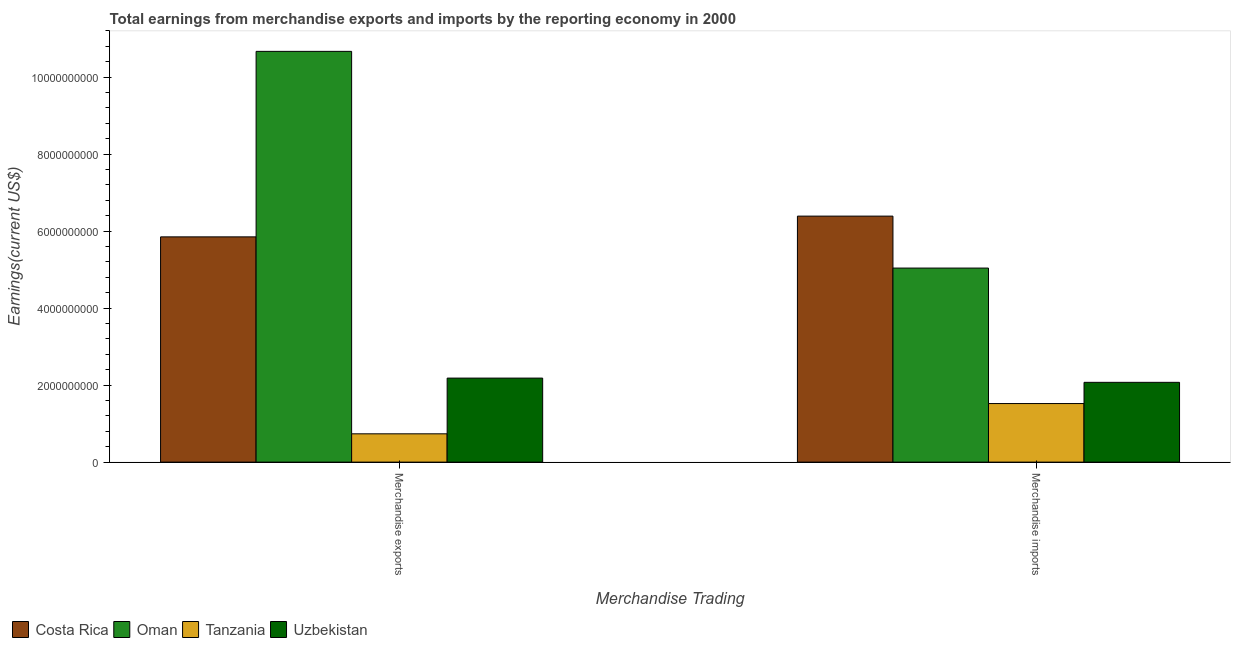How many different coloured bars are there?
Offer a terse response. 4. How many groups of bars are there?
Offer a terse response. 2. Are the number of bars on each tick of the X-axis equal?
Keep it short and to the point. Yes. How many bars are there on the 1st tick from the right?
Your answer should be compact. 4. What is the label of the 2nd group of bars from the left?
Give a very brief answer. Merchandise imports. What is the earnings from merchandise exports in Uzbekistan?
Make the answer very short. 2.18e+09. Across all countries, what is the maximum earnings from merchandise exports?
Your response must be concise. 1.07e+1. Across all countries, what is the minimum earnings from merchandise imports?
Offer a terse response. 1.52e+09. In which country was the earnings from merchandise exports maximum?
Keep it short and to the point. Oman. In which country was the earnings from merchandise exports minimum?
Offer a terse response. Tanzania. What is the total earnings from merchandise exports in the graph?
Keep it short and to the point. 1.94e+1. What is the difference between the earnings from merchandise exports in Uzbekistan and that in Oman?
Make the answer very short. -8.48e+09. What is the difference between the earnings from merchandise imports in Oman and the earnings from merchandise exports in Uzbekistan?
Give a very brief answer. 2.86e+09. What is the average earnings from merchandise imports per country?
Give a very brief answer. 3.76e+09. What is the difference between the earnings from merchandise exports and earnings from merchandise imports in Costa Rica?
Your response must be concise. -5.39e+08. In how many countries, is the earnings from merchandise exports greater than 400000000 US$?
Offer a terse response. 4. What is the ratio of the earnings from merchandise imports in Uzbekistan to that in Tanzania?
Offer a very short reply. 1.36. In how many countries, is the earnings from merchandise exports greater than the average earnings from merchandise exports taken over all countries?
Offer a terse response. 2. What does the 2nd bar from the left in Merchandise exports represents?
Ensure brevity in your answer.  Oman. What does the 1st bar from the right in Merchandise imports represents?
Offer a terse response. Uzbekistan. How many countries are there in the graph?
Give a very brief answer. 4. Does the graph contain any zero values?
Offer a very short reply. No. Where does the legend appear in the graph?
Ensure brevity in your answer.  Bottom left. How many legend labels are there?
Provide a succinct answer. 4. How are the legend labels stacked?
Make the answer very short. Horizontal. What is the title of the graph?
Provide a short and direct response. Total earnings from merchandise exports and imports by the reporting economy in 2000. Does "Hungary" appear as one of the legend labels in the graph?
Make the answer very short. No. What is the label or title of the X-axis?
Your answer should be very brief. Merchandise Trading. What is the label or title of the Y-axis?
Provide a succinct answer. Earnings(current US$). What is the Earnings(current US$) of Costa Rica in Merchandise exports?
Your response must be concise. 5.85e+09. What is the Earnings(current US$) in Oman in Merchandise exports?
Give a very brief answer. 1.07e+1. What is the Earnings(current US$) of Tanzania in Merchandise exports?
Make the answer very short. 7.35e+08. What is the Earnings(current US$) in Uzbekistan in Merchandise exports?
Ensure brevity in your answer.  2.18e+09. What is the Earnings(current US$) of Costa Rica in Merchandise imports?
Offer a terse response. 6.39e+09. What is the Earnings(current US$) in Oman in Merchandise imports?
Your answer should be compact. 5.04e+09. What is the Earnings(current US$) in Tanzania in Merchandise imports?
Give a very brief answer. 1.52e+09. What is the Earnings(current US$) in Uzbekistan in Merchandise imports?
Your answer should be compact. 2.07e+09. Across all Merchandise Trading, what is the maximum Earnings(current US$) of Costa Rica?
Provide a succinct answer. 6.39e+09. Across all Merchandise Trading, what is the maximum Earnings(current US$) of Oman?
Keep it short and to the point. 1.07e+1. Across all Merchandise Trading, what is the maximum Earnings(current US$) of Tanzania?
Provide a succinct answer. 1.52e+09. Across all Merchandise Trading, what is the maximum Earnings(current US$) of Uzbekistan?
Offer a very short reply. 2.18e+09. Across all Merchandise Trading, what is the minimum Earnings(current US$) in Costa Rica?
Your answer should be very brief. 5.85e+09. Across all Merchandise Trading, what is the minimum Earnings(current US$) in Oman?
Your answer should be compact. 5.04e+09. Across all Merchandise Trading, what is the minimum Earnings(current US$) of Tanzania?
Your answer should be very brief. 7.35e+08. Across all Merchandise Trading, what is the minimum Earnings(current US$) of Uzbekistan?
Provide a succinct answer. 2.07e+09. What is the total Earnings(current US$) in Costa Rica in the graph?
Make the answer very short. 1.22e+1. What is the total Earnings(current US$) in Oman in the graph?
Offer a very short reply. 1.57e+1. What is the total Earnings(current US$) of Tanzania in the graph?
Ensure brevity in your answer.  2.26e+09. What is the total Earnings(current US$) in Uzbekistan in the graph?
Your response must be concise. 4.25e+09. What is the difference between the Earnings(current US$) of Costa Rica in Merchandise exports and that in Merchandise imports?
Offer a very short reply. -5.39e+08. What is the difference between the Earnings(current US$) in Oman in Merchandise exports and that in Merchandise imports?
Provide a short and direct response. 5.63e+09. What is the difference between the Earnings(current US$) of Tanzania in Merchandise exports and that in Merchandise imports?
Your response must be concise. -7.86e+08. What is the difference between the Earnings(current US$) in Uzbekistan in Merchandise exports and that in Merchandise imports?
Make the answer very short. 1.10e+08. What is the difference between the Earnings(current US$) in Costa Rica in Merchandise exports and the Earnings(current US$) in Oman in Merchandise imports?
Keep it short and to the point. 8.10e+08. What is the difference between the Earnings(current US$) in Costa Rica in Merchandise exports and the Earnings(current US$) in Tanzania in Merchandise imports?
Your answer should be compact. 4.33e+09. What is the difference between the Earnings(current US$) of Costa Rica in Merchandise exports and the Earnings(current US$) of Uzbekistan in Merchandise imports?
Provide a short and direct response. 3.78e+09. What is the difference between the Earnings(current US$) of Oman in Merchandise exports and the Earnings(current US$) of Tanzania in Merchandise imports?
Offer a terse response. 9.15e+09. What is the difference between the Earnings(current US$) of Oman in Merchandise exports and the Earnings(current US$) of Uzbekistan in Merchandise imports?
Provide a short and direct response. 8.59e+09. What is the difference between the Earnings(current US$) in Tanzania in Merchandise exports and the Earnings(current US$) in Uzbekistan in Merchandise imports?
Provide a short and direct response. -1.34e+09. What is the average Earnings(current US$) of Costa Rica per Merchandise Trading?
Your answer should be very brief. 6.12e+09. What is the average Earnings(current US$) of Oman per Merchandise Trading?
Your answer should be very brief. 7.85e+09. What is the average Earnings(current US$) in Tanzania per Merchandise Trading?
Provide a short and direct response. 1.13e+09. What is the average Earnings(current US$) in Uzbekistan per Merchandise Trading?
Offer a very short reply. 2.13e+09. What is the difference between the Earnings(current US$) in Costa Rica and Earnings(current US$) in Oman in Merchandise exports?
Give a very brief answer. -4.82e+09. What is the difference between the Earnings(current US$) of Costa Rica and Earnings(current US$) of Tanzania in Merchandise exports?
Your answer should be very brief. 5.11e+09. What is the difference between the Earnings(current US$) in Costa Rica and Earnings(current US$) in Uzbekistan in Merchandise exports?
Give a very brief answer. 3.67e+09. What is the difference between the Earnings(current US$) of Oman and Earnings(current US$) of Tanzania in Merchandise exports?
Your answer should be compact. 9.93e+09. What is the difference between the Earnings(current US$) in Oman and Earnings(current US$) in Uzbekistan in Merchandise exports?
Make the answer very short. 8.48e+09. What is the difference between the Earnings(current US$) of Tanzania and Earnings(current US$) of Uzbekistan in Merchandise exports?
Provide a short and direct response. -1.45e+09. What is the difference between the Earnings(current US$) in Costa Rica and Earnings(current US$) in Oman in Merchandise imports?
Provide a succinct answer. 1.35e+09. What is the difference between the Earnings(current US$) in Costa Rica and Earnings(current US$) in Tanzania in Merchandise imports?
Provide a short and direct response. 4.87e+09. What is the difference between the Earnings(current US$) in Costa Rica and Earnings(current US$) in Uzbekistan in Merchandise imports?
Provide a short and direct response. 4.32e+09. What is the difference between the Earnings(current US$) in Oman and Earnings(current US$) in Tanzania in Merchandise imports?
Your answer should be very brief. 3.52e+09. What is the difference between the Earnings(current US$) of Oman and Earnings(current US$) of Uzbekistan in Merchandise imports?
Your response must be concise. 2.97e+09. What is the difference between the Earnings(current US$) in Tanzania and Earnings(current US$) in Uzbekistan in Merchandise imports?
Keep it short and to the point. -5.51e+08. What is the ratio of the Earnings(current US$) of Costa Rica in Merchandise exports to that in Merchandise imports?
Ensure brevity in your answer.  0.92. What is the ratio of the Earnings(current US$) of Oman in Merchandise exports to that in Merchandise imports?
Your response must be concise. 2.12. What is the ratio of the Earnings(current US$) of Tanzania in Merchandise exports to that in Merchandise imports?
Offer a very short reply. 0.48. What is the ratio of the Earnings(current US$) in Uzbekistan in Merchandise exports to that in Merchandise imports?
Provide a succinct answer. 1.05. What is the difference between the highest and the second highest Earnings(current US$) of Costa Rica?
Offer a terse response. 5.39e+08. What is the difference between the highest and the second highest Earnings(current US$) of Oman?
Keep it short and to the point. 5.63e+09. What is the difference between the highest and the second highest Earnings(current US$) of Tanzania?
Provide a short and direct response. 7.86e+08. What is the difference between the highest and the second highest Earnings(current US$) in Uzbekistan?
Keep it short and to the point. 1.10e+08. What is the difference between the highest and the lowest Earnings(current US$) of Costa Rica?
Offer a terse response. 5.39e+08. What is the difference between the highest and the lowest Earnings(current US$) of Oman?
Make the answer very short. 5.63e+09. What is the difference between the highest and the lowest Earnings(current US$) of Tanzania?
Offer a very short reply. 7.86e+08. What is the difference between the highest and the lowest Earnings(current US$) in Uzbekistan?
Provide a short and direct response. 1.10e+08. 